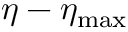<formula> <loc_0><loc_0><loc_500><loc_500>\eta - \eta _ { \max }</formula> 